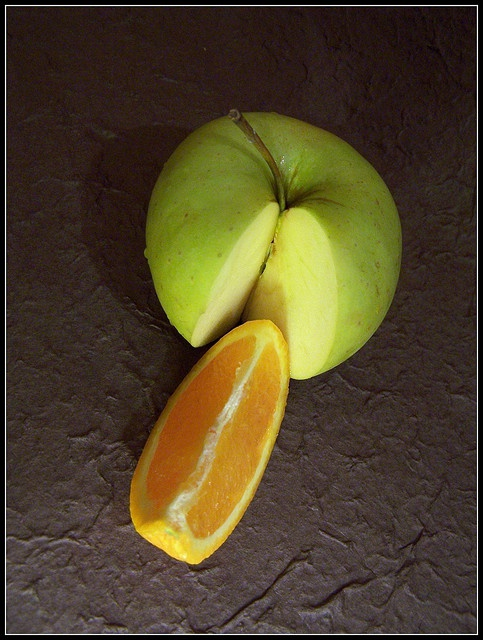Describe the objects in this image and their specific colors. I can see apple in black, olive, and khaki tones and orange in black, brown, orange, and khaki tones in this image. 